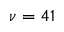<formula> <loc_0><loc_0><loc_500><loc_500>\nu = 4 1</formula> 